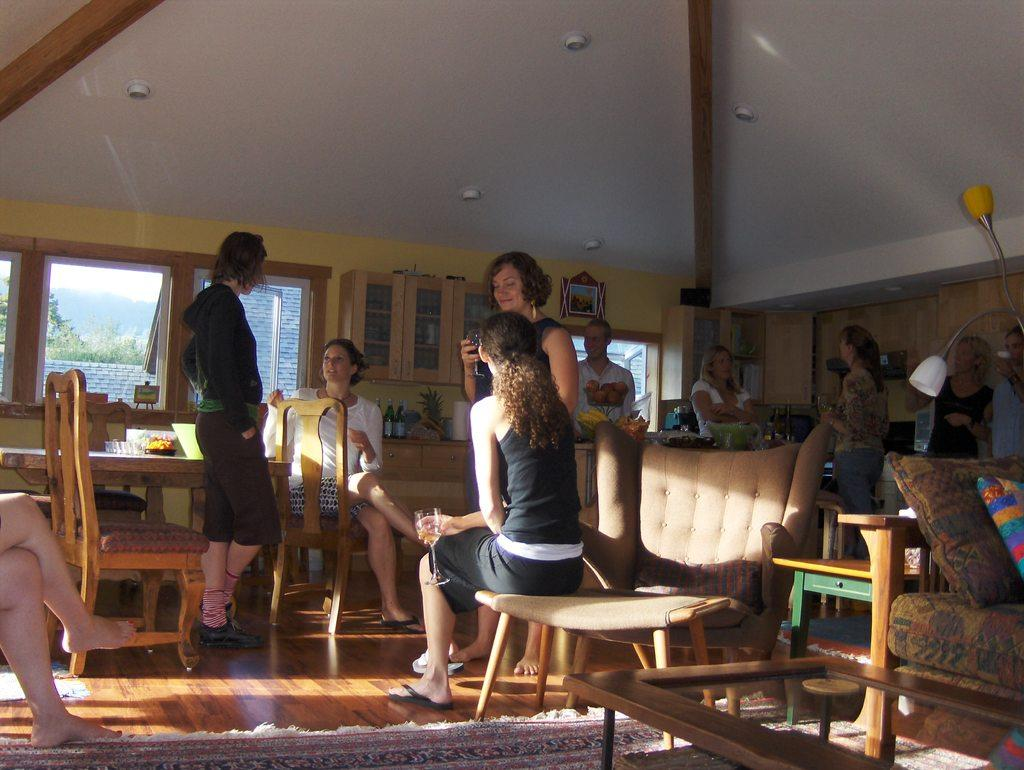How many people are in the image? There is a group of people in the image, but the exact number is not specified. What are some of the people in the image doing? Some people are sitting on chairs, while others are standing. What type of furniture is present in the image? There are tables present in the image. What can be seen through the window in the image? The fact does not specify what can be seen through the window. What type of thrill can be experienced by visiting the cemetery in the image? There is no cemetery present in the image, so it is not possible to experience any thrill related to a cemetery. 